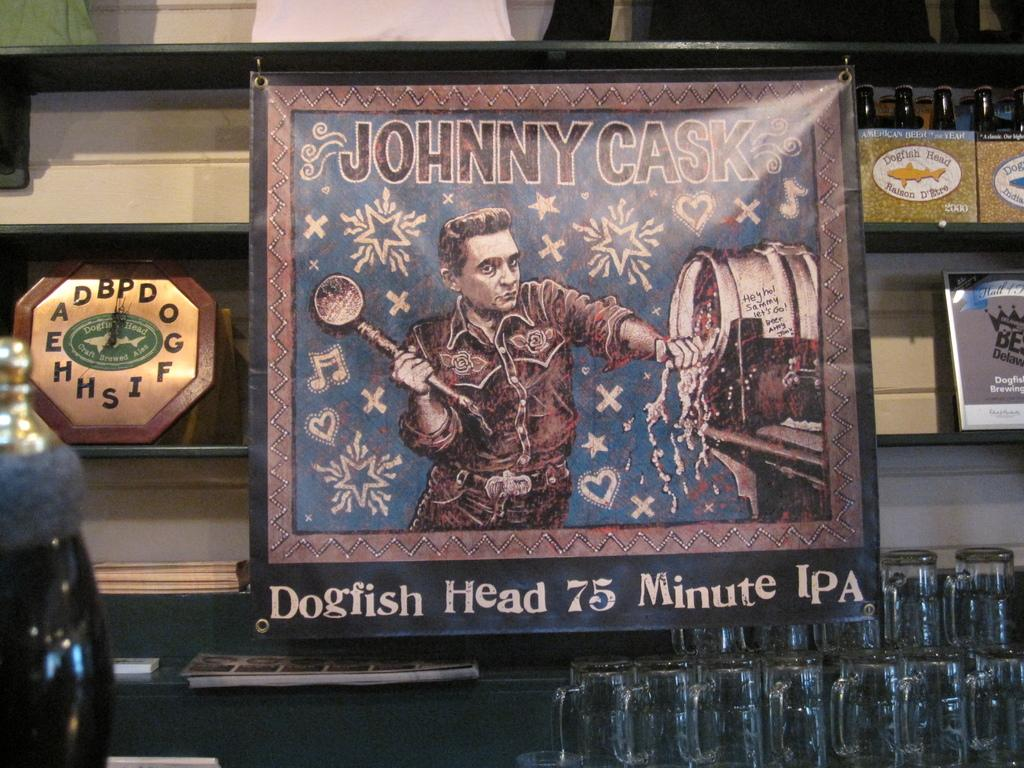<image>
Give a short and clear explanation of the subsequent image. A bar displays beer mugs under a Johnny Cask brand beer banner. 